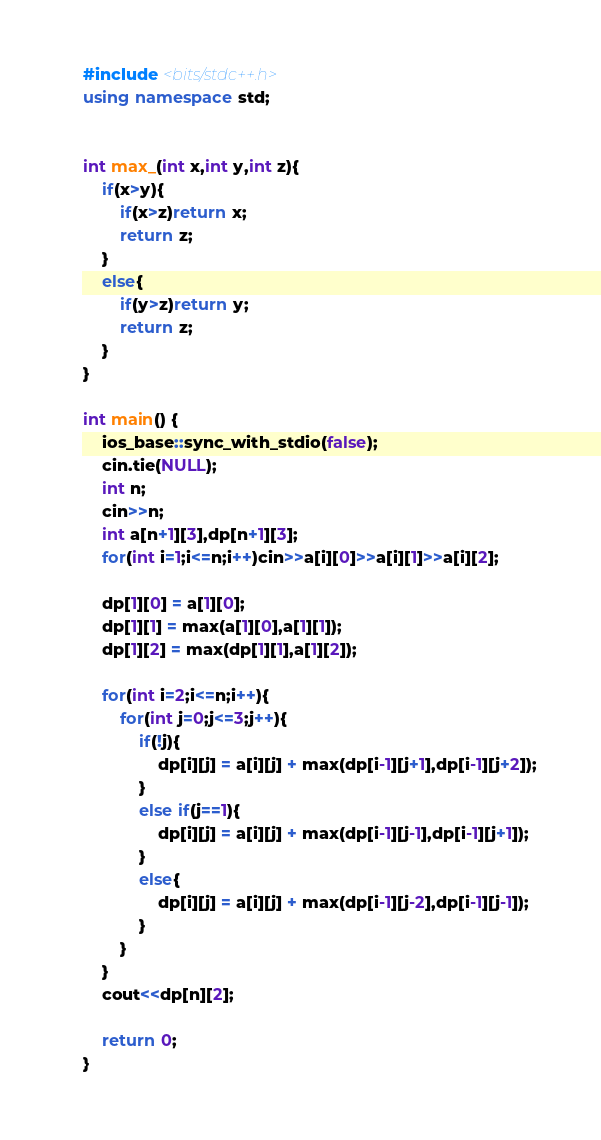<code> <loc_0><loc_0><loc_500><loc_500><_C++_>#include <bits/stdc++.h>
using namespace std;


int max_(int x,int y,int z){
    if(x>y){
        if(x>z)return x;
        return z;
    }
    else{
        if(y>z)return y;
        return z;
    }
}

int main() {
    ios_base::sync_with_stdio(false);
    cin.tie(NULL);
    int n;
    cin>>n;
    int a[n+1][3],dp[n+1][3];
    for(int i=1;i<=n;i++)cin>>a[i][0]>>a[i][1]>>a[i][2];
    
    dp[1][0] = a[1][0];
    dp[1][1] = max(a[1][0],a[1][1]);
    dp[1][2] = max(dp[1][1],a[1][2]);

    for(int i=2;i<=n;i++){
        for(int j=0;j<=3;j++){
            if(!j){
                dp[i][j] = a[i][j] + max(dp[i-1][j+1],dp[i-1][j+2]);
            }
            else if(j==1){
                dp[i][j] = a[i][j] + max(dp[i-1][j-1],dp[i-1][j+1]);
            }
            else{
                dp[i][j] = a[i][j] + max(dp[i-1][j-2],dp[i-1][j-1]);
            }
        }        
    }
    cout<<dp[n][2];
    
    return 0;
}    </code> 